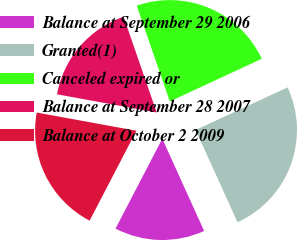<chart> <loc_0><loc_0><loc_500><loc_500><pie_chart><fcel>Balance at September 29 2006<fcel>Granted(1)<fcel>Canceled expired or<fcel>Balance at September 28 2007<fcel>Balance at October 2 2009<nl><fcel>14.41%<fcel>25.13%<fcel>23.39%<fcel>16.83%<fcel>20.24%<nl></chart> 